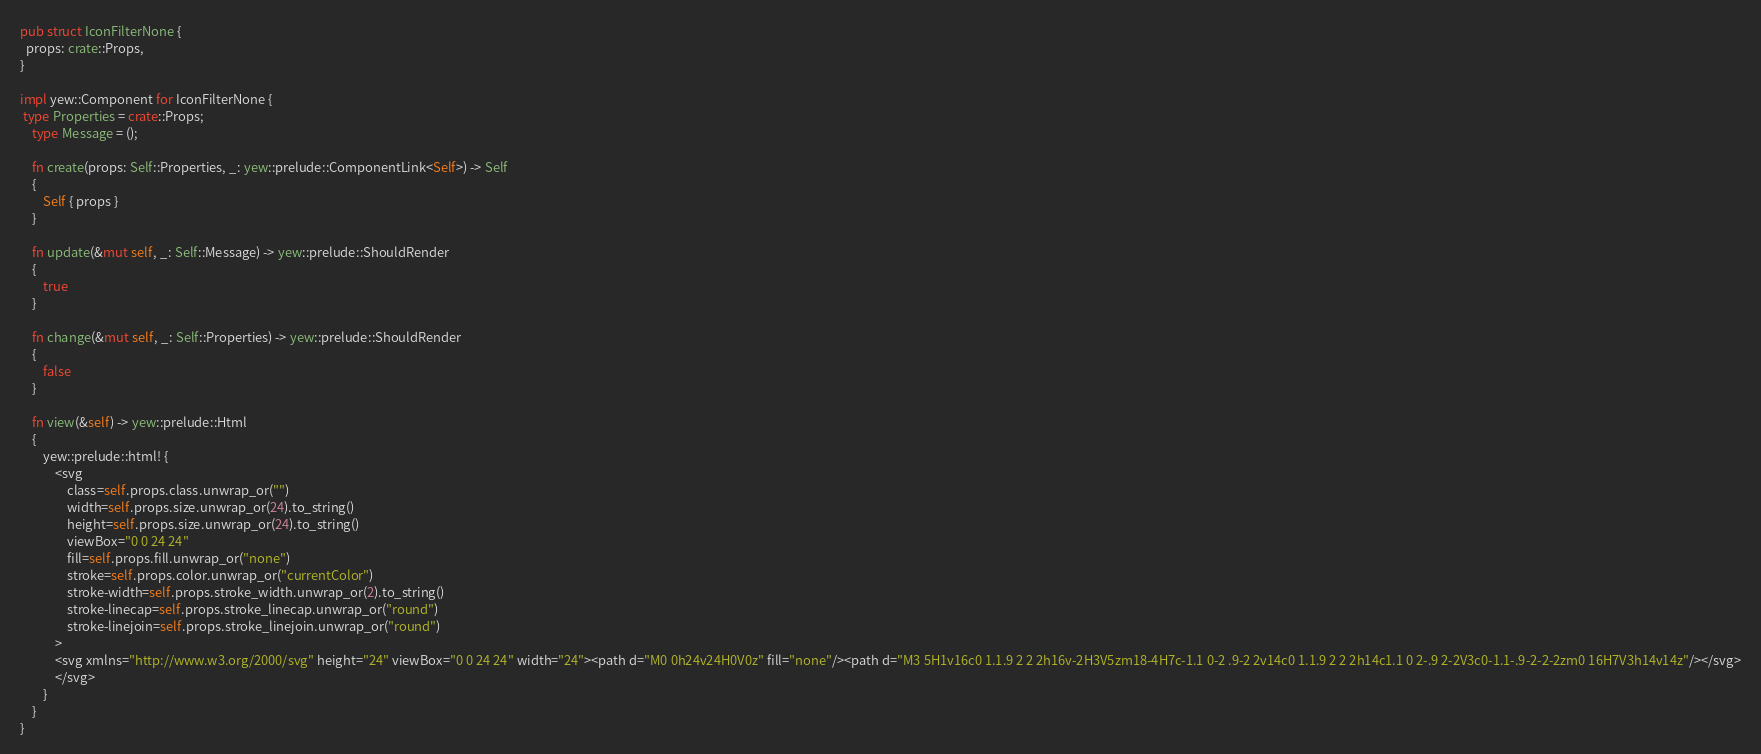Convert code to text. <code><loc_0><loc_0><loc_500><loc_500><_Rust_>
pub struct IconFilterNone {
  props: crate::Props,
}

impl yew::Component for IconFilterNone {
 type Properties = crate::Props;
    type Message = ();

    fn create(props: Self::Properties, _: yew::prelude::ComponentLink<Self>) -> Self
    {
        Self { props }
    }

    fn update(&mut self, _: Self::Message) -> yew::prelude::ShouldRender
    {
        true
    }

    fn change(&mut self, _: Self::Properties) -> yew::prelude::ShouldRender
    {
        false
    }

    fn view(&self) -> yew::prelude::Html
    {
        yew::prelude::html! {
            <svg
                class=self.props.class.unwrap_or("")
                width=self.props.size.unwrap_or(24).to_string()
                height=self.props.size.unwrap_or(24).to_string()
                viewBox="0 0 24 24"
                fill=self.props.fill.unwrap_or("none")
                stroke=self.props.color.unwrap_or("currentColor")
                stroke-width=self.props.stroke_width.unwrap_or(2).to_string()
                stroke-linecap=self.props.stroke_linecap.unwrap_or("round")
                stroke-linejoin=self.props.stroke_linejoin.unwrap_or("round")
            >
            <svg xmlns="http://www.w3.org/2000/svg" height="24" viewBox="0 0 24 24" width="24"><path d="M0 0h24v24H0V0z" fill="none"/><path d="M3 5H1v16c0 1.1.9 2 2 2h16v-2H3V5zm18-4H7c-1.1 0-2 .9-2 2v14c0 1.1.9 2 2 2h14c1.1 0 2-.9 2-2V3c0-1.1-.9-2-2-2zm0 16H7V3h14v14z"/></svg>
            </svg>
        }
    }
}


</code> 